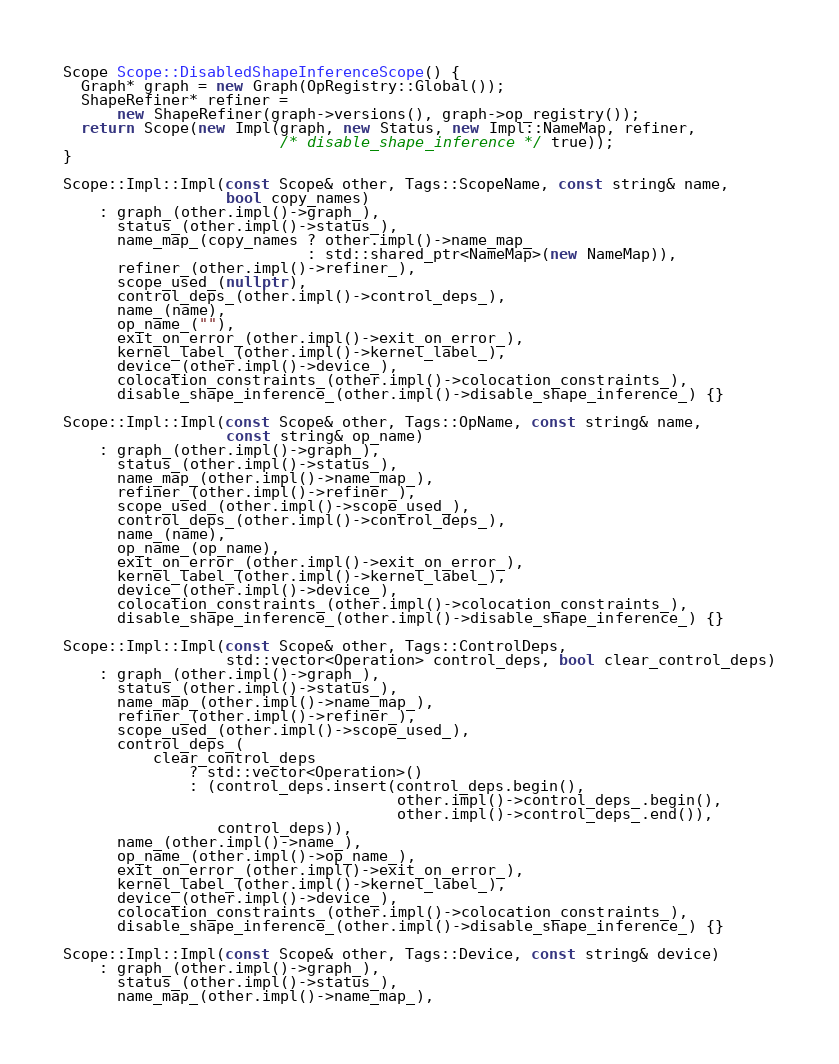Convert code to text. <code><loc_0><loc_0><loc_500><loc_500><_C++_>
Scope Scope::DisabledShapeInferenceScope() {
  Graph* graph = new Graph(OpRegistry::Global());
  ShapeRefiner* refiner =
      new ShapeRefiner(graph->versions(), graph->op_registry());
  return Scope(new Impl(graph, new Status, new Impl::NameMap, refiner,
                        /* disable_shape_inference */ true));
}

Scope::Impl::Impl(const Scope& other, Tags::ScopeName, const string& name,
                  bool copy_names)
    : graph_(other.impl()->graph_),
      status_(other.impl()->status_),
      name_map_(copy_names ? other.impl()->name_map_
                           : std::shared_ptr<NameMap>(new NameMap)),
      refiner_(other.impl()->refiner_),
      scope_used_(nullptr),
      control_deps_(other.impl()->control_deps_),
      name_(name),
      op_name_(""),
      exit_on_error_(other.impl()->exit_on_error_),
      kernel_label_(other.impl()->kernel_label_),
      device_(other.impl()->device_),
      colocation_constraints_(other.impl()->colocation_constraints_),
      disable_shape_inference_(other.impl()->disable_shape_inference_) {}

Scope::Impl::Impl(const Scope& other, Tags::OpName, const string& name,
                  const string& op_name)
    : graph_(other.impl()->graph_),
      status_(other.impl()->status_),
      name_map_(other.impl()->name_map_),
      refiner_(other.impl()->refiner_),
      scope_used_(other.impl()->scope_used_),
      control_deps_(other.impl()->control_deps_),
      name_(name),
      op_name_(op_name),
      exit_on_error_(other.impl()->exit_on_error_),
      kernel_label_(other.impl()->kernel_label_),
      device_(other.impl()->device_),
      colocation_constraints_(other.impl()->colocation_constraints_),
      disable_shape_inference_(other.impl()->disable_shape_inference_) {}

Scope::Impl::Impl(const Scope& other, Tags::ControlDeps,
                  std::vector<Operation> control_deps, bool clear_control_deps)
    : graph_(other.impl()->graph_),
      status_(other.impl()->status_),
      name_map_(other.impl()->name_map_),
      refiner_(other.impl()->refiner_),
      scope_used_(other.impl()->scope_used_),
      control_deps_(
          clear_control_deps
              ? std::vector<Operation>()
              : (control_deps.insert(control_deps.begin(),
                                     other.impl()->control_deps_.begin(),
                                     other.impl()->control_deps_.end()),
                 control_deps)),
      name_(other.impl()->name_),
      op_name_(other.impl()->op_name_),
      exit_on_error_(other.impl()->exit_on_error_),
      kernel_label_(other.impl()->kernel_label_),
      device_(other.impl()->device_),
      colocation_constraints_(other.impl()->colocation_constraints_),
      disable_shape_inference_(other.impl()->disable_shape_inference_) {}

Scope::Impl::Impl(const Scope& other, Tags::Device, const string& device)
    : graph_(other.impl()->graph_),
      status_(other.impl()->status_),
      name_map_(other.impl()->name_map_),</code> 